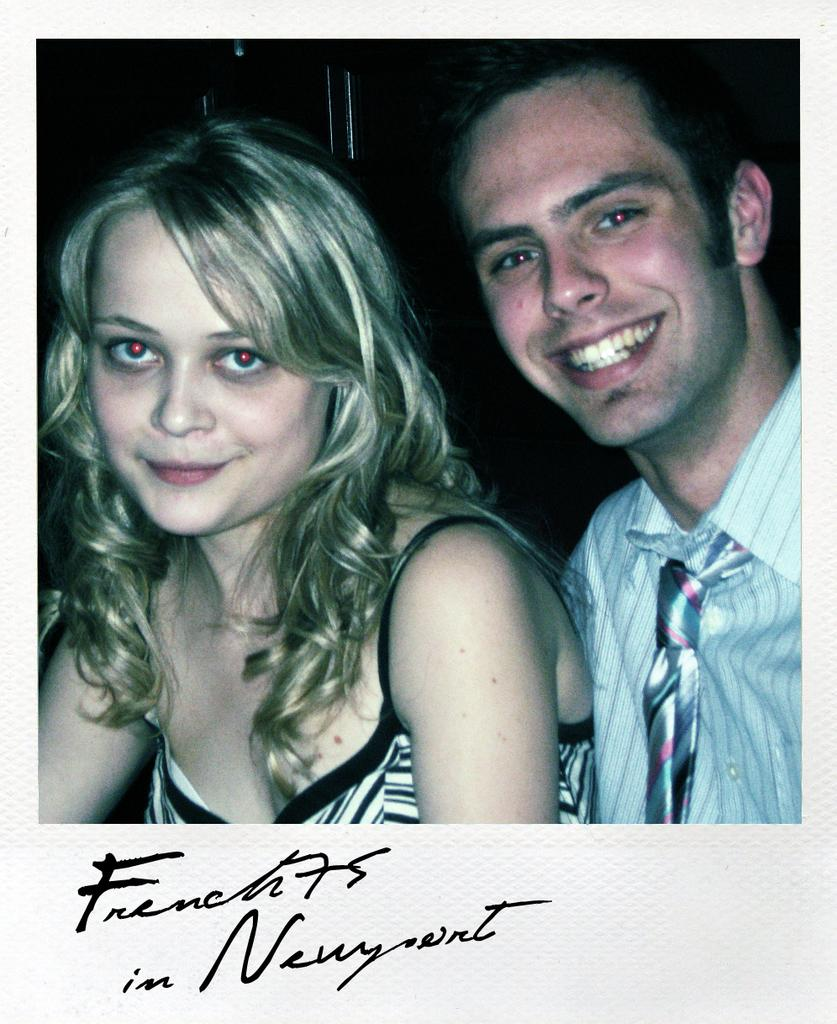How many people are in the image? There are persons in the image, but the exact number is not specified. What are the persons wearing? The persons are wearing clothes. What can be found at the bottom of the image? There is text at the bottom of the image. What type of force is being exerted by the dinosaurs in the image? There are no dinosaurs present in the image, so it is not possible to determine the type of force being exerted by them. 